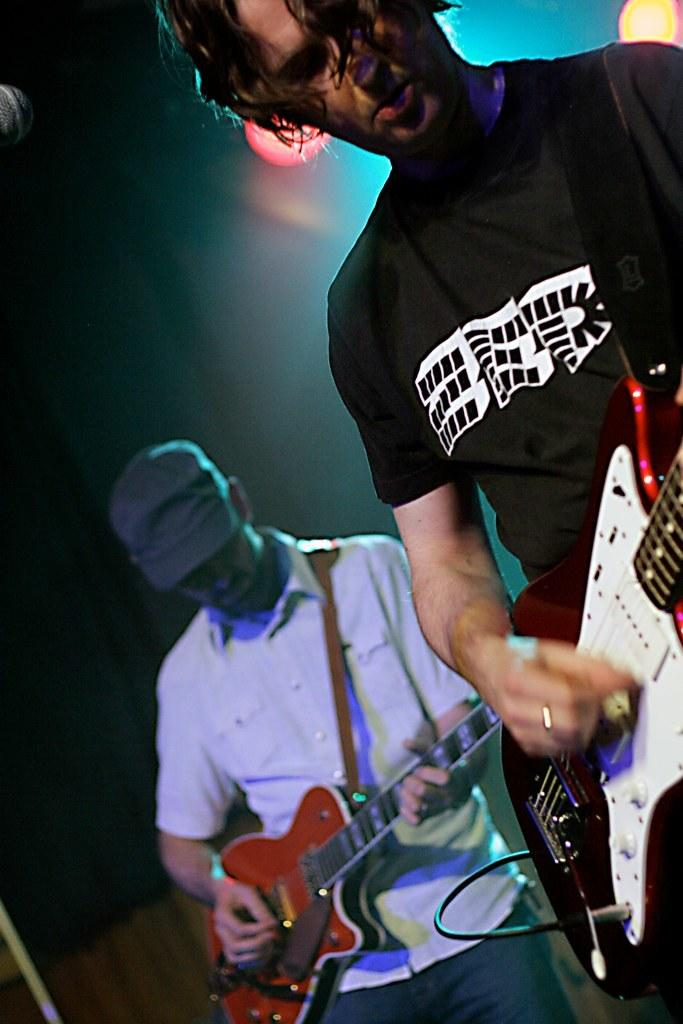How many people are in the image? There are two people in the image. What are the two people doing in the image? The two people are playing guitars. Can you describe any lighting or color in the image? There is a red color light attached to the roof in the background. What event might the image be capturing? The image was taken at a musical concert. What type of pear is hanging from the guitar in the image? There is no pear present in the image, nor is there any pear hanging from the guitar. 